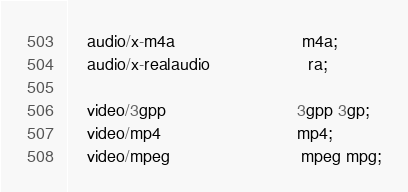<code> <loc_0><loc_0><loc_500><loc_500><_MoonScript_>    audio/x-m4a                           m4a;
    audio/x-realaudio                     ra;

    video/3gpp                            3gpp 3gp;
    video/mp4                             mp4;
    video/mpeg                            mpeg mpg;</code> 